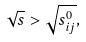Convert formula to latex. <formula><loc_0><loc_0><loc_500><loc_500>\sqrt { s } > \sqrt { s ^ { 0 } _ { i j } } ,</formula> 